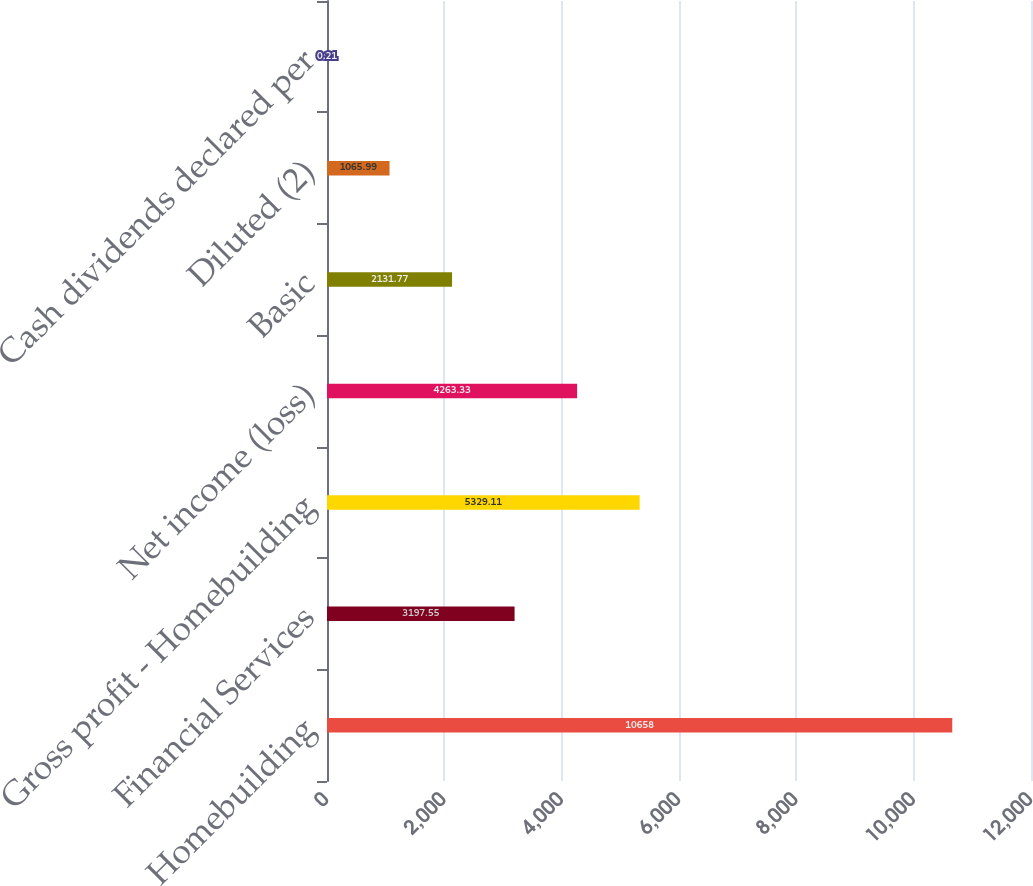Convert chart. <chart><loc_0><loc_0><loc_500><loc_500><bar_chart><fcel>Homebuilding<fcel>Financial Services<fcel>Gross profit - Homebuilding<fcel>Net income (loss)<fcel>Basic<fcel>Diluted (2)<fcel>Cash dividends declared per<nl><fcel>10658<fcel>3197.55<fcel>5329.11<fcel>4263.33<fcel>2131.77<fcel>1065.99<fcel>0.21<nl></chart> 